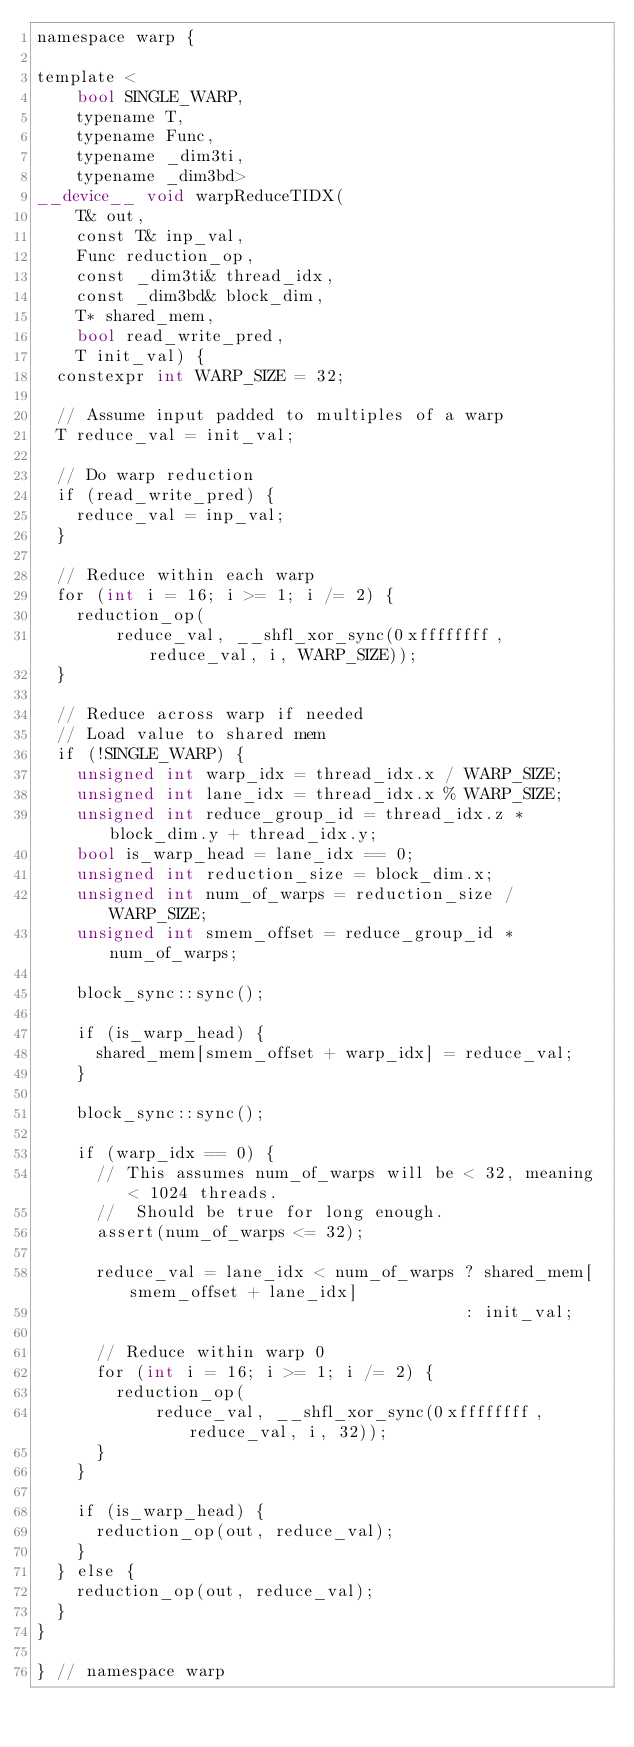Convert code to text. <code><loc_0><loc_0><loc_500><loc_500><_Cuda_>namespace warp {

template <
    bool SINGLE_WARP,
    typename T,
    typename Func,
    typename _dim3ti,
    typename _dim3bd>
__device__ void warpReduceTIDX(
    T& out,
    const T& inp_val,
    Func reduction_op,
    const _dim3ti& thread_idx,
    const _dim3bd& block_dim,
    T* shared_mem,
    bool read_write_pred,
    T init_val) {
  constexpr int WARP_SIZE = 32;

  // Assume input padded to multiples of a warp
  T reduce_val = init_val;

  // Do warp reduction
  if (read_write_pred) {
    reduce_val = inp_val;
  }

  // Reduce within each warp
  for (int i = 16; i >= 1; i /= 2) {
    reduction_op(
        reduce_val, __shfl_xor_sync(0xffffffff, reduce_val, i, WARP_SIZE));
  }

  // Reduce across warp if needed
  // Load value to shared mem
  if (!SINGLE_WARP) {
    unsigned int warp_idx = thread_idx.x / WARP_SIZE;
    unsigned int lane_idx = thread_idx.x % WARP_SIZE;
    unsigned int reduce_group_id = thread_idx.z * block_dim.y + thread_idx.y;
    bool is_warp_head = lane_idx == 0;
    unsigned int reduction_size = block_dim.x;
    unsigned int num_of_warps = reduction_size / WARP_SIZE;
    unsigned int smem_offset = reduce_group_id * num_of_warps;

    block_sync::sync();

    if (is_warp_head) {
      shared_mem[smem_offset + warp_idx] = reduce_val;
    }

    block_sync::sync();

    if (warp_idx == 0) {
      // This assumes num_of_warps will be < 32, meaning < 1024 threads.
      //  Should be true for long enough.
      assert(num_of_warps <= 32);

      reduce_val = lane_idx < num_of_warps ? shared_mem[smem_offset + lane_idx]
                                           : init_val;

      // Reduce within warp 0
      for (int i = 16; i >= 1; i /= 2) {
        reduction_op(
            reduce_val, __shfl_xor_sync(0xffffffff, reduce_val, i, 32));
      }
    }

    if (is_warp_head) {
      reduction_op(out, reduce_val);
    }
  } else {
    reduction_op(out, reduce_val);
  }
}

} // namespace warp
</code> 